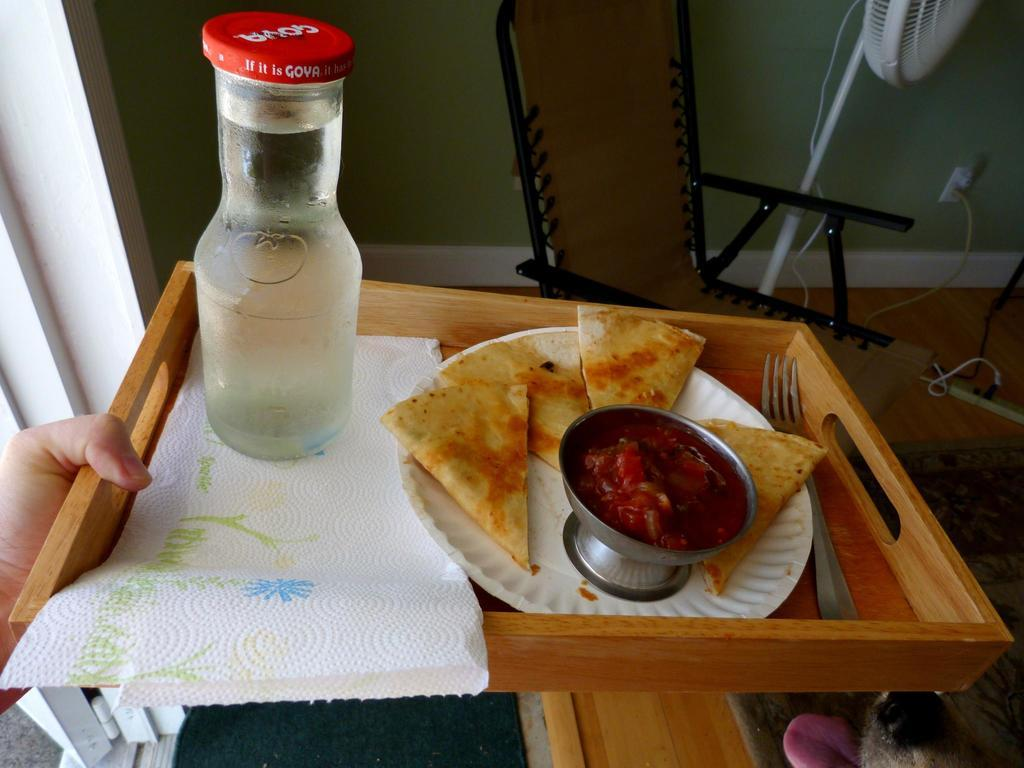Provide a one-sentence caption for the provided image. Goya brand milk goes well with quesadilla snacks. 